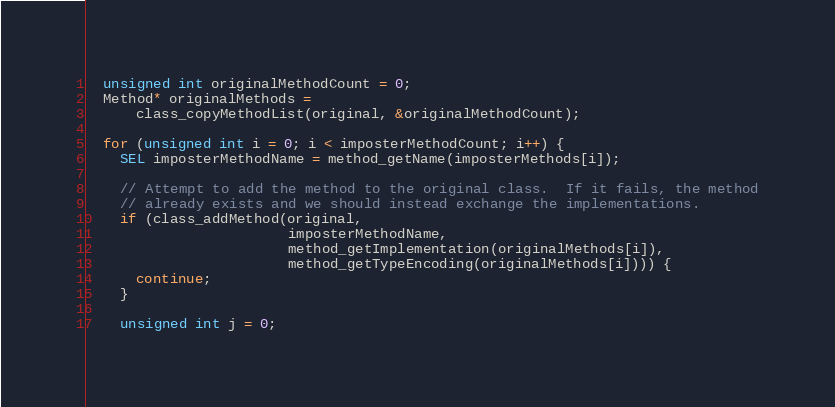Convert code to text. <code><loc_0><loc_0><loc_500><loc_500><_ObjectiveC_>
  unsigned int originalMethodCount = 0;
  Method* originalMethods =
      class_copyMethodList(original, &originalMethodCount);

  for (unsigned int i = 0; i < imposterMethodCount; i++) {
    SEL imposterMethodName = method_getName(imposterMethods[i]);

    // Attempt to add the method to the original class.  If it fails, the method
    // already exists and we should instead exchange the implementations.
    if (class_addMethod(original,
                        imposterMethodName,
                        method_getImplementation(originalMethods[i]),
                        method_getTypeEncoding(originalMethods[i]))) {
      continue;
    }

    unsigned int j = 0;</code> 